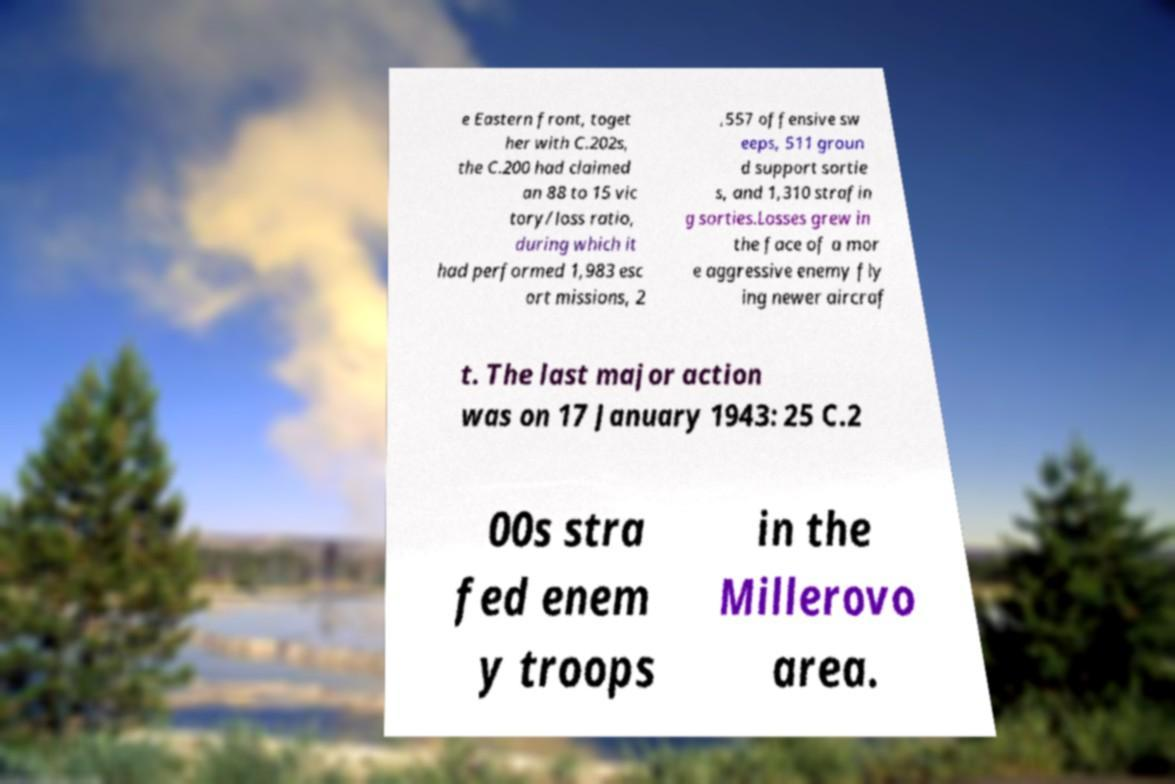Could you assist in decoding the text presented in this image and type it out clearly? e Eastern front, toget her with C.202s, the C.200 had claimed an 88 to 15 vic tory/loss ratio, during which it had performed 1,983 esc ort missions, 2 ,557 offensive sw eeps, 511 groun d support sortie s, and 1,310 strafin g sorties.Losses grew in the face of a mor e aggressive enemy fly ing newer aircraf t. The last major action was on 17 January 1943: 25 C.2 00s stra fed enem y troops in the Millerovo area. 